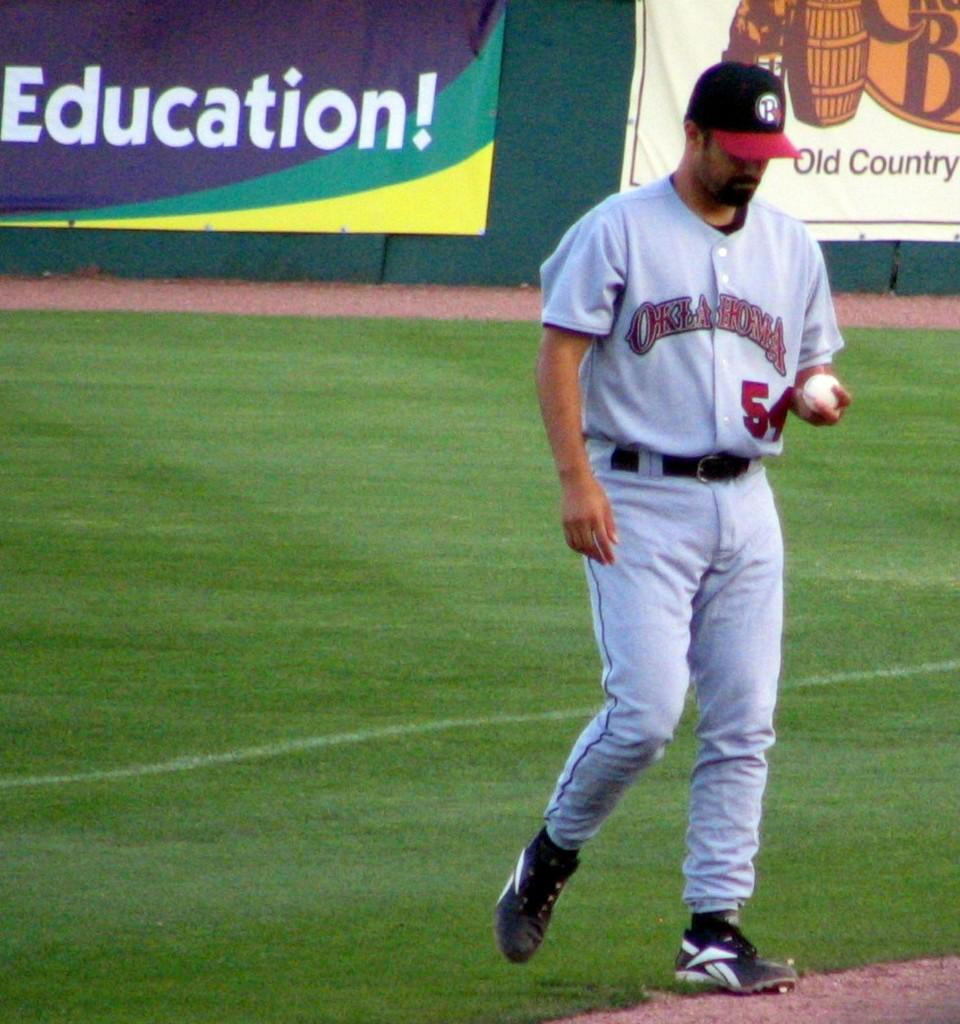<image>
Create a compact narrative representing the image presented. a player that is wearing the number 5 on their jersey 